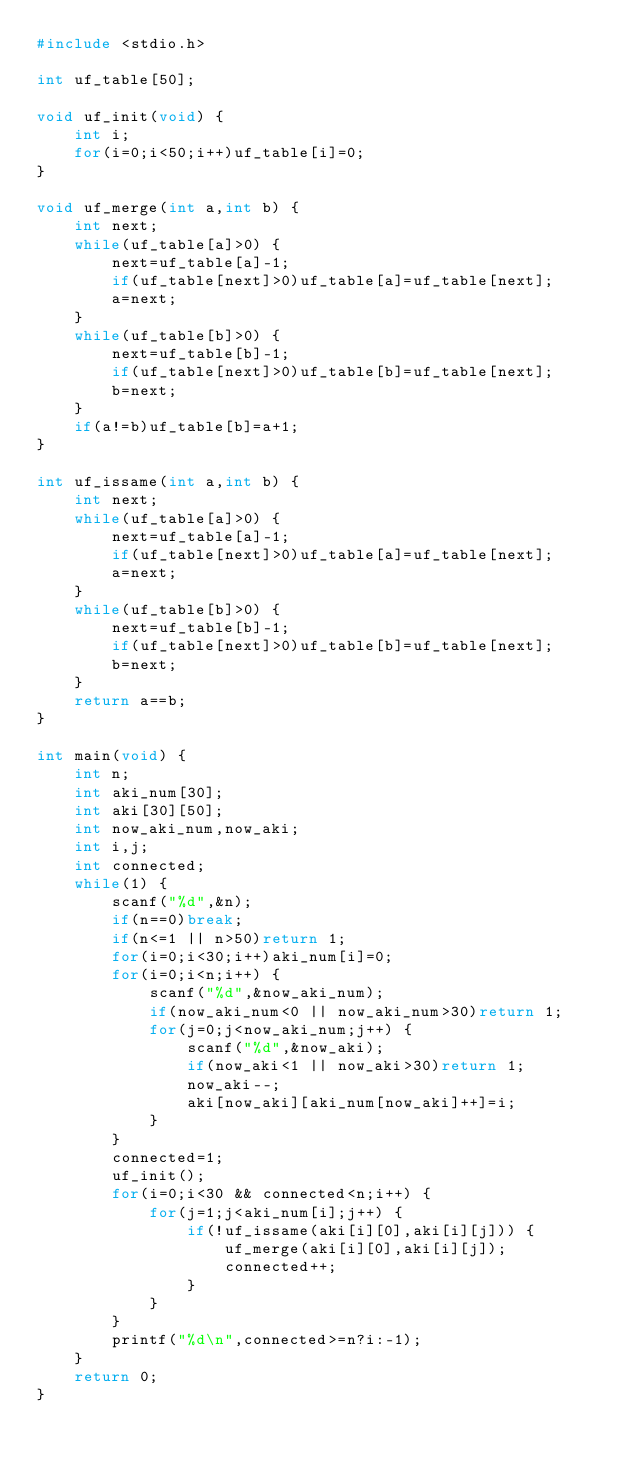<code> <loc_0><loc_0><loc_500><loc_500><_C_>#include <stdio.h>

int uf_table[50];

void uf_init(void) {
	int i;
	for(i=0;i<50;i++)uf_table[i]=0;
}

void uf_merge(int a,int b) {
	int next;
	while(uf_table[a]>0) {
		next=uf_table[a]-1;
		if(uf_table[next]>0)uf_table[a]=uf_table[next];
		a=next;
	}
	while(uf_table[b]>0) {
		next=uf_table[b]-1;
		if(uf_table[next]>0)uf_table[b]=uf_table[next];
		b=next;
	}
	if(a!=b)uf_table[b]=a+1;
}

int uf_issame(int a,int b) {
	int next;
	while(uf_table[a]>0) {
		next=uf_table[a]-1;
		if(uf_table[next]>0)uf_table[a]=uf_table[next];
		a=next;
	}
	while(uf_table[b]>0) {
		next=uf_table[b]-1;
		if(uf_table[next]>0)uf_table[b]=uf_table[next];
		b=next;
	}
	return a==b;
}

int main(void) {
	int n;
	int aki_num[30];
	int aki[30][50];
	int now_aki_num,now_aki;
	int i,j;
	int connected;
	while(1) {
		scanf("%d",&n);
		if(n==0)break;
		if(n<=1 || n>50)return 1;
		for(i=0;i<30;i++)aki_num[i]=0;
		for(i=0;i<n;i++) {
			scanf("%d",&now_aki_num);
			if(now_aki_num<0 || now_aki_num>30)return 1;
			for(j=0;j<now_aki_num;j++) {
				scanf("%d",&now_aki);
				if(now_aki<1 || now_aki>30)return 1;
				now_aki--;
				aki[now_aki][aki_num[now_aki]++]=i;
			}
		}
		connected=1;
		uf_init();
		for(i=0;i<30 && connected<n;i++) {
			for(j=1;j<aki_num[i];j++) {
				if(!uf_issame(aki[i][0],aki[i][j])) {
					uf_merge(aki[i][0],aki[i][j]);
					connected++;
				}
			}
		}
		printf("%d\n",connected>=n?i:-1);
	}
	return 0;
}</code> 